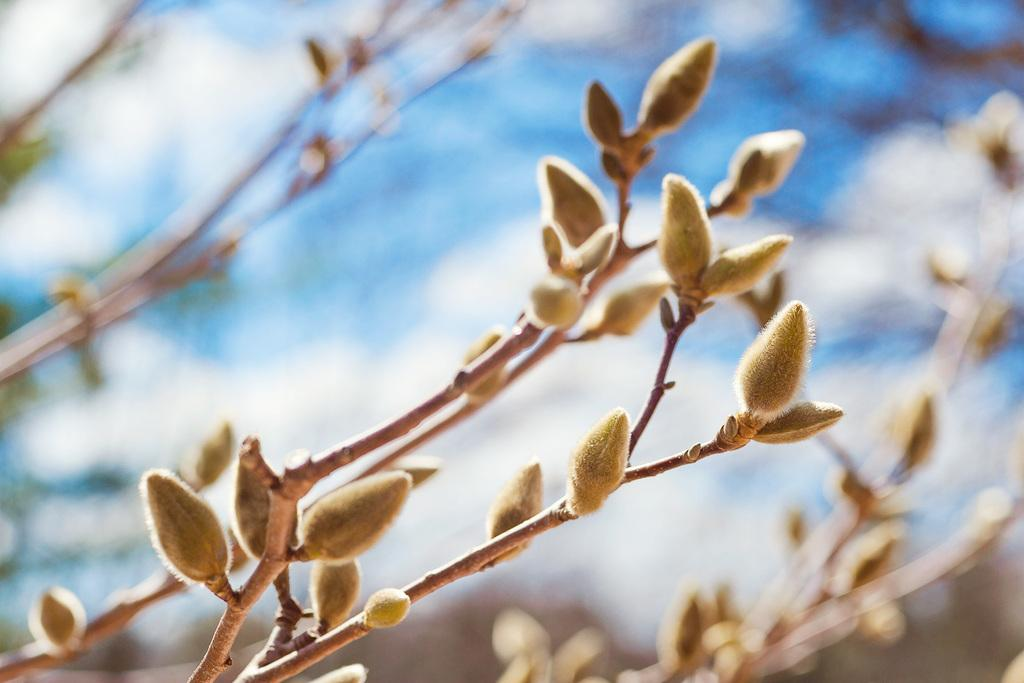What is present in the image? There is a plant in the image. What can be observed on the plant? There are cream-colored buds on the plant. What type of screw is being used by the representative in the image? There is no screw or representative present in the image; it only features a plant with cream-colored buds. 